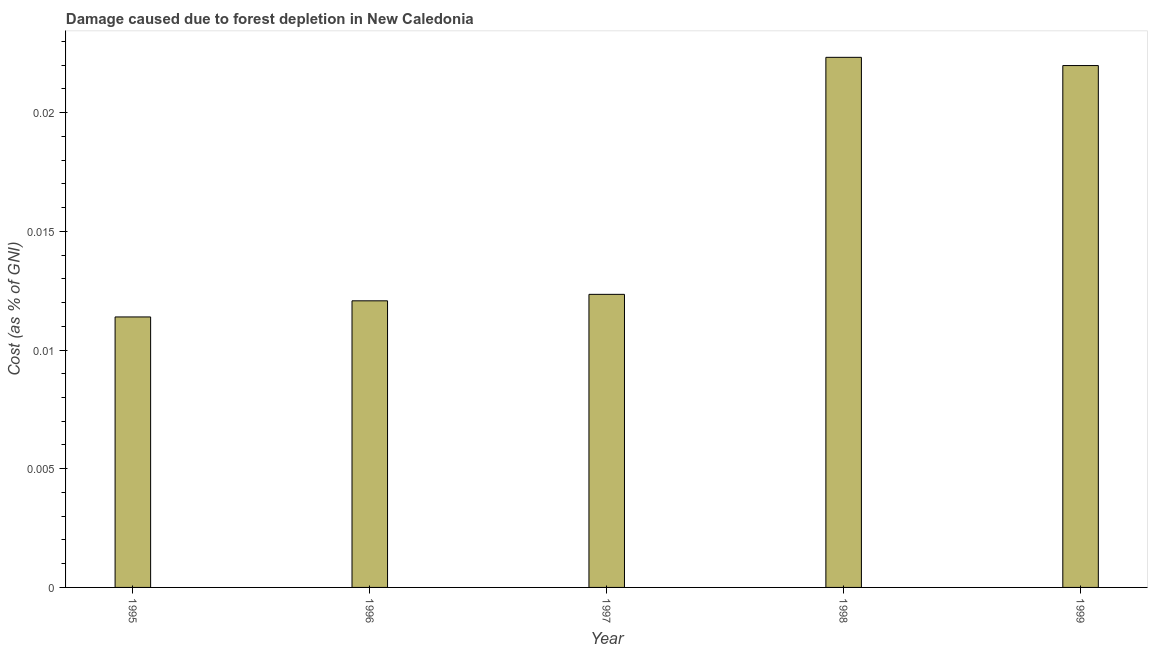What is the title of the graph?
Offer a very short reply. Damage caused due to forest depletion in New Caledonia. What is the label or title of the Y-axis?
Your response must be concise. Cost (as % of GNI). What is the damage caused due to forest depletion in 1998?
Ensure brevity in your answer.  0.02. Across all years, what is the maximum damage caused due to forest depletion?
Your answer should be very brief. 0.02. Across all years, what is the minimum damage caused due to forest depletion?
Your answer should be very brief. 0.01. In which year was the damage caused due to forest depletion minimum?
Ensure brevity in your answer.  1995. What is the sum of the damage caused due to forest depletion?
Your response must be concise. 0.08. What is the difference between the damage caused due to forest depletion in 1998 and 1999?
Provide a short and direct response. 0. What is the average damage caused due to forest depletion per year?
Ensure brevity in your answer.  0.02. What is the median damage caused due to forest depletion?
Give a very brief answer. 0.01. Do a majority of the years between 1997 and 1996 (inclusive) have damage caused due to forest depletion greater than 0.001 %?
Keep it short and to the point. No. What is the ratio of the damage caused due to forest depletion in 1995 to that in 1996?
Offer a very short reply. 0.94. Is the damage caused due to forest depletion in 1998 less than that in 1999?
Give a very brief answer. No. What is the difference between the highest and the second highest damage caused due to forest depletion?
Keep it short and to the point. 0. Is the sum of the damage caused due to forest depletion in 1996 and 1999 greater than the maximum damage caused due to forest depletion across all years?
Offer a very short reply. Yes. What is the difference between the highest and the lowest damage caused due to forest depletion?
Ensure brevity in your answer.  0.01. How many bars are there?
Provide a succinct answer. 5. How many years are there in the graph?
Keep it short and to the point. 5. What is the difference between two consecutive major ticks on the Y-axis?
Your answer should be very brief. 0.01. Are the values on the major ticks of Y-axis written in scientific E-notation?
Your response must be concise. No. What is the Cost (as % of GNI) of 1995?
Provide a short and direct response. 0.01. What is the Cost (as % of GNI) in 1996?
Keep it short and to the point. 0.01. What is the Cost (as % of GNI) in 1997?
Your response must be concise. 0.01. What is the Cost (as % of GNI) in 1998?
Offer a very short reply. 0.02. What is the Cost (as % of GNI) in 1999?
Your answer should be very brief. 0.02. What is the difference between the Cost (as % of GNI) in 1995 and 1996?
Provide a short and direct response. -0. What is the difference between the Cost (as % of GNI) in 1995 and 1997?
Give a very brief answer. -0. What is the difference between the Cost (as % of GNI) in 1995 and 1998?
Provide a short and direct response. -0.01. What is the difference between the Cost (as % of GNI) in 1995 and 1999?
Offer a very short reply. -0.01. What is the difference between the Cost (as % of GNI) in 1996 and 1997?
Keep it short and to the point. -0. What is the difference between the Cost (as % of GNI) in 1996 and 1998?
Ensure brevity in your answer.  -0.01. What is the difference between the Cost (as % of GNI) in 1996 and 1999?
Give a very brief answer. -0.01. What is the difference between the Cost (as % of GNI) in 1997 and 1998?
Give a very brief answer. -0.01. What is the difference between the Cost (as % of GNI) in 1997 and 1999?
Provide a short and direct response. -0.01. What is the difference between the Cost (as % of GNI) in 1998 and 1999?
Keep it short and to the point. 0. What is the ratio of the Cost (as % of GNI) in 1995 to that in 1996?
Your response must be concise. 0.94. What is the ratio of the Cost (as % of GNI) in 1995 to that in 1997?
Provide a succinct answer. 0.92. What is the ratio of the Cost (as % of GNI) in 1995 to that in 1998?
Your answer should be very brief. 0.51. What is the ratio of the Cost (as % of GNI) in 1995 to that in 1999?
Your answer should be very brief. 0.52. What is the ratio of the Cost (as % of GNI) in 1996 to that in 1997?
Your response must be concise. 0.98. What is the ratio of the Cost (as % of GNI) in 1996 to that in 1998?
Keep it short and to the point. 0.54. What is the ratio of the Cost (as % of GNI) in 1996 to that in 1999?
Your response must be concise. 0.55. What is the ratio of the Cost (as % of GNI) in 1997 to that in 1998?
Your answer should be very brief. 0.55. What is the ratio of the Cost (as % of GNI) in 1997 to that in 1999?
Give a very brief answer. 0.56. 